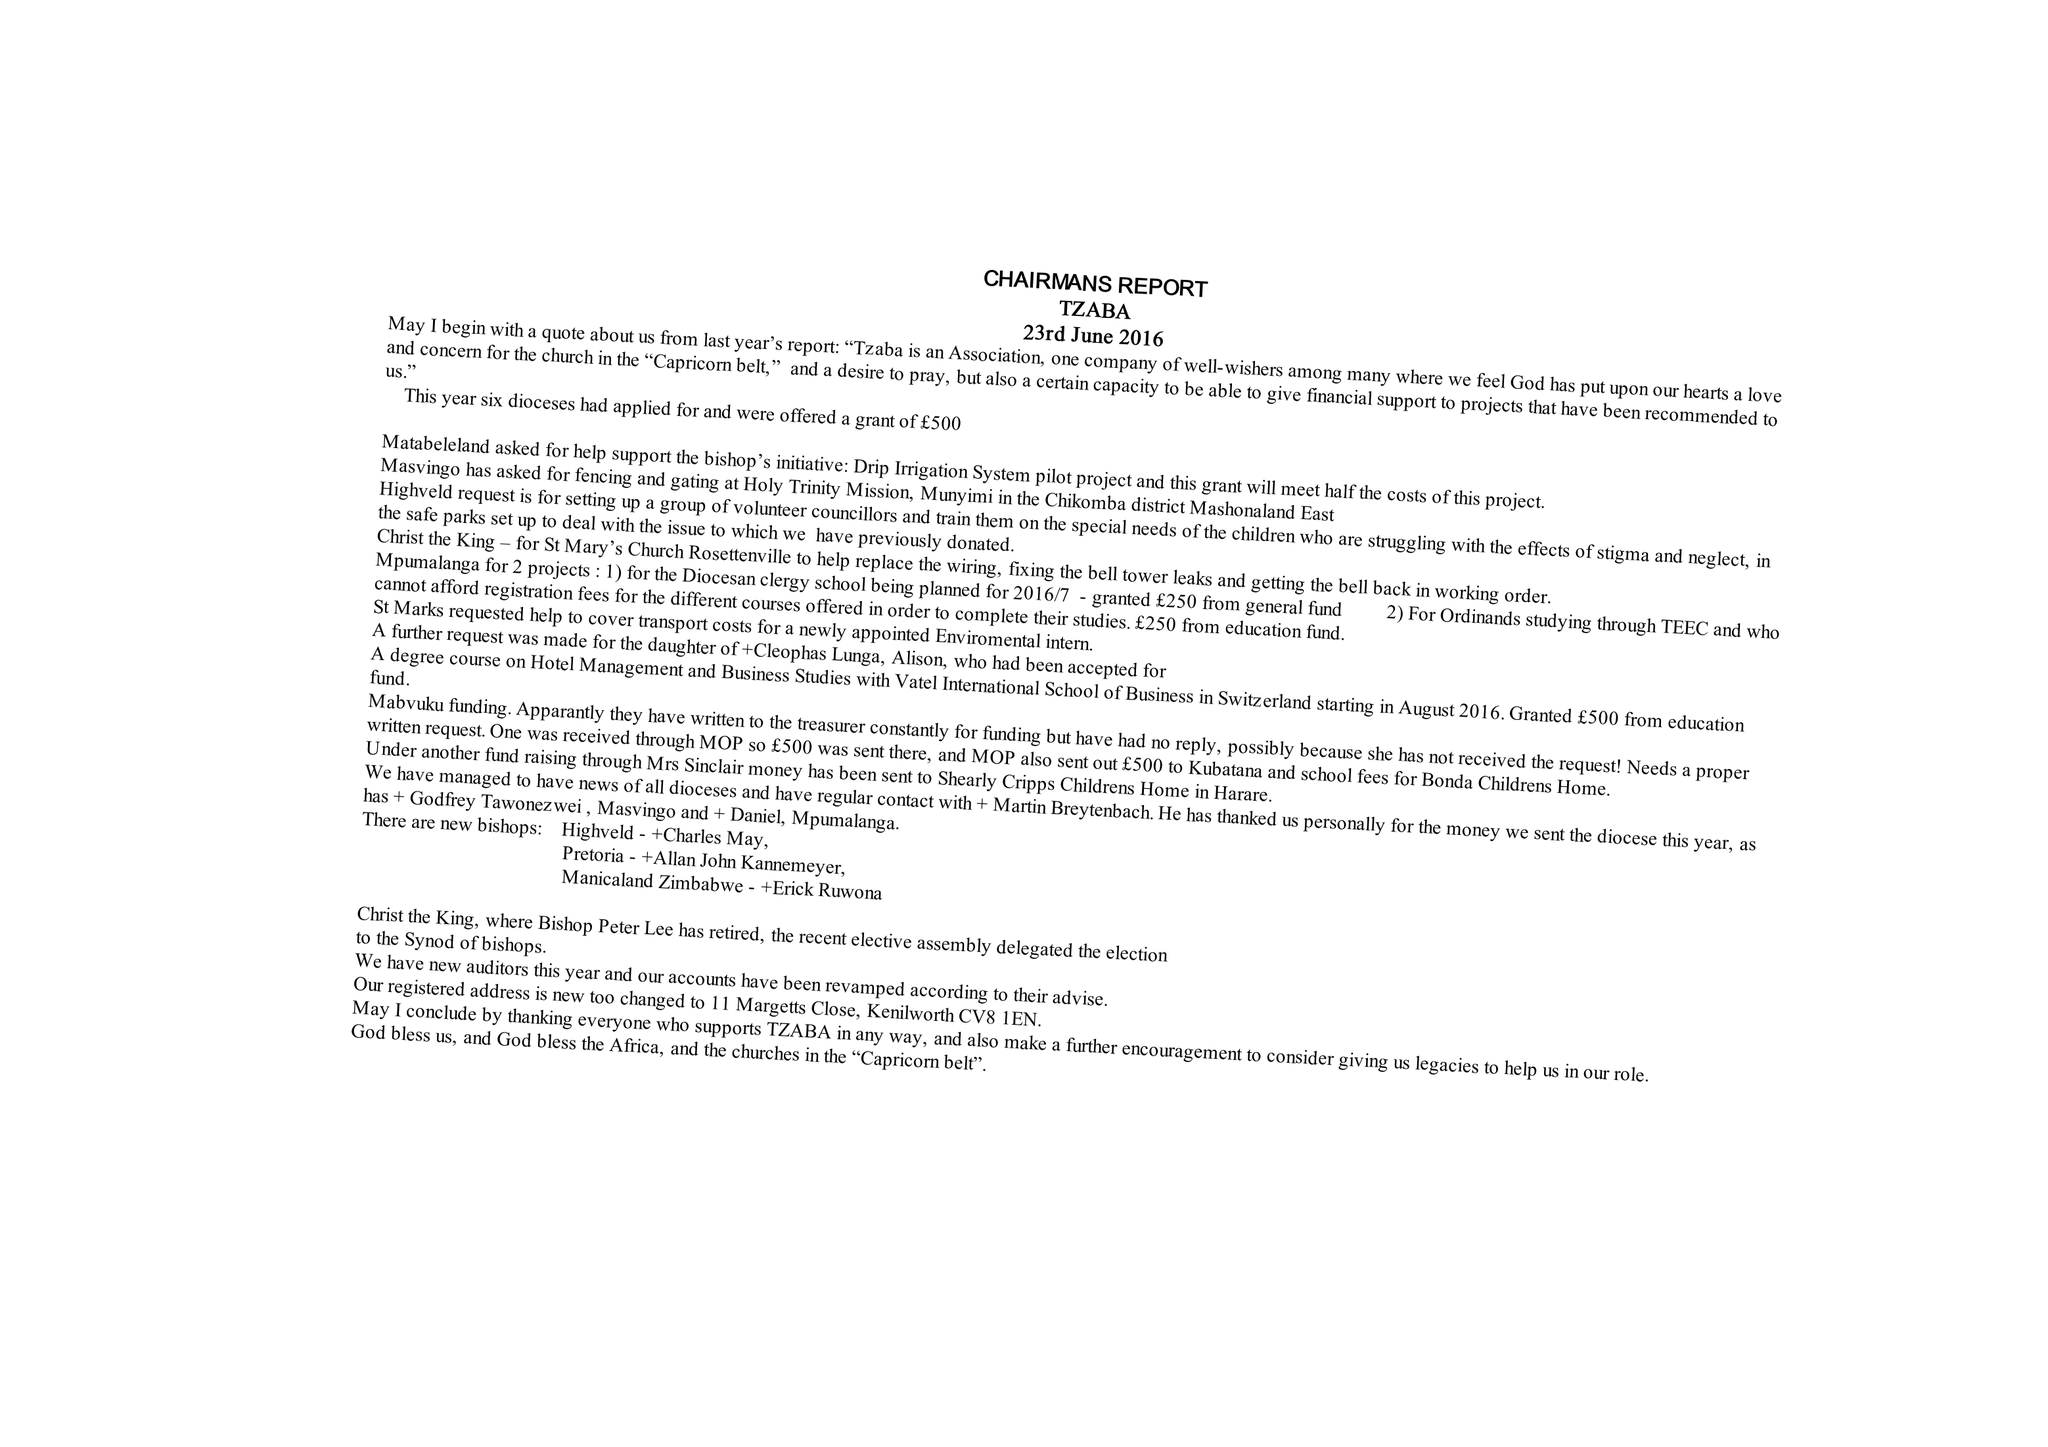What is the value for the spending_annually_in_british_pounds?
Answer the question using a single word or phrase. 39157.00 